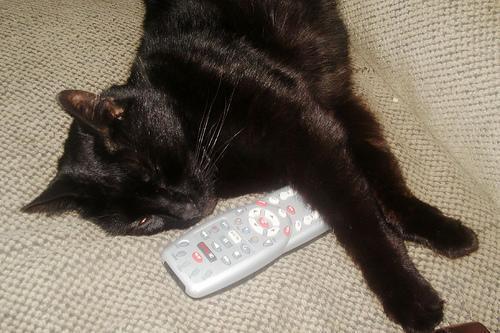How many remotes are there?
Give a very brief answer. 1. How many people are on the pommel lift?
Give a very brief answer. 0. 